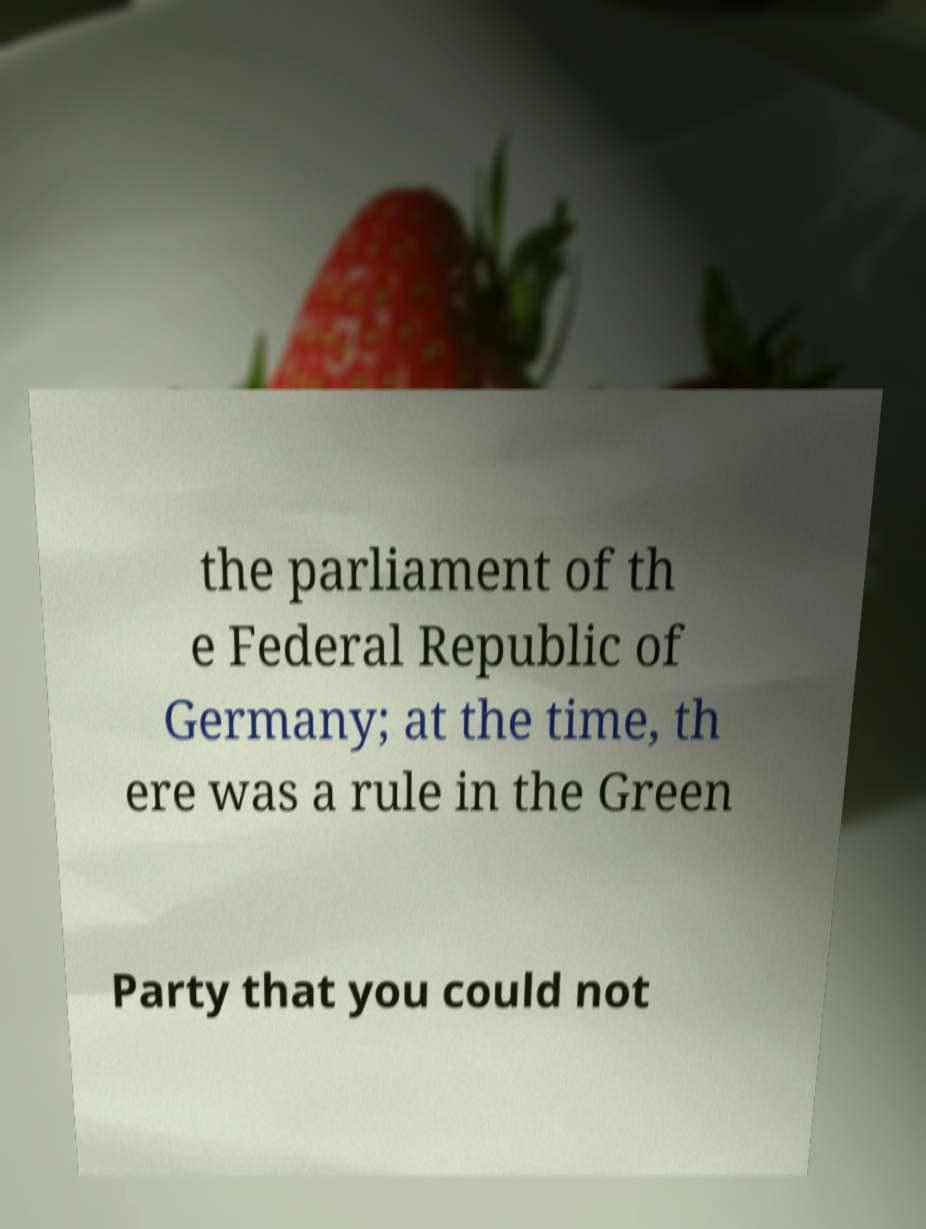Could you assist in decoding the text presented in this image and type it out clearly? the parliament of th e Federal Republic of Germany; at the time, th ere was a rule in the Green Party that you could not 